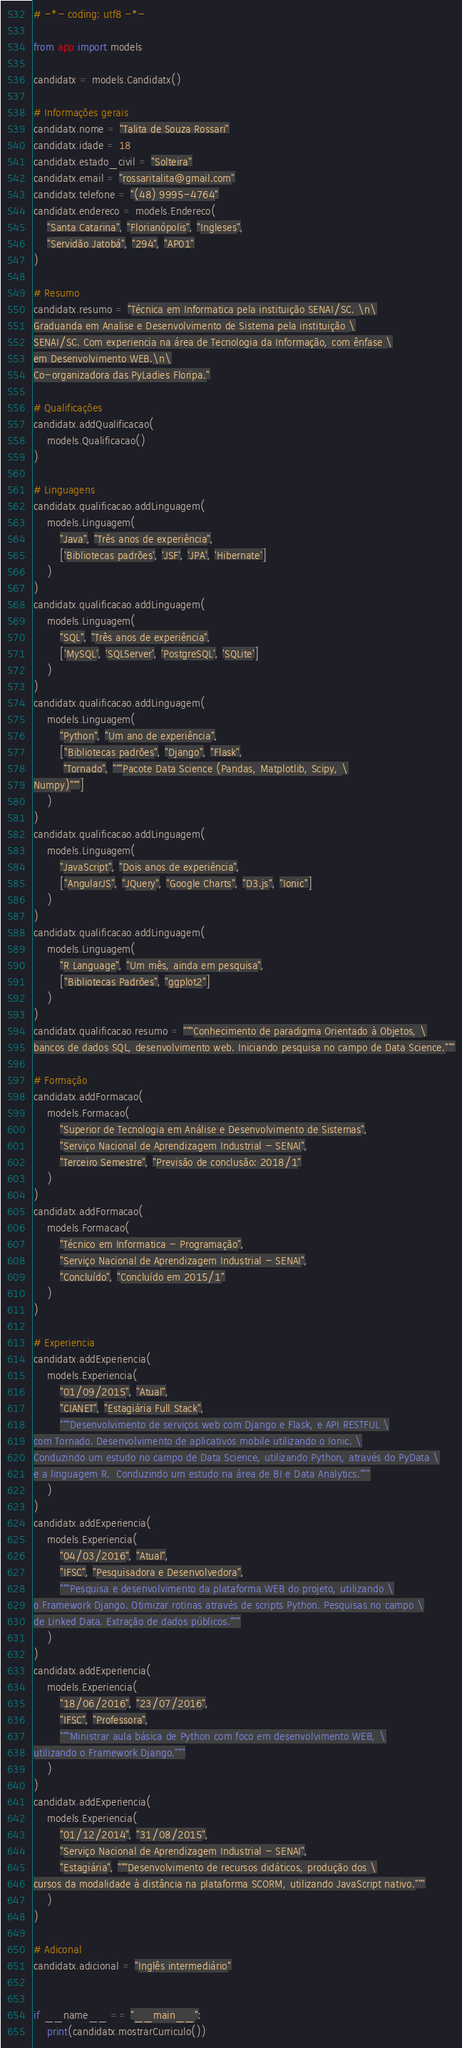Convert code to text. <code><loc_0><loc_0><loc_500><loc_500><_Python_># -*- coding: utf8 -*-

from app import models

candidatx = models.Candidatx()

# Informações gerais
candidatx.nome = "Talita de Souza Rossari"
candidatx.idade = 18
candidatx.estado_civil = "Solteira"
candidatx.email = "rossaritalita@gmail.com"
candidatx.telefone = "(48) 9995-4764"
candidatx.endereco = models.Endereco(
    "Santa Catarina", "Florianópolis", "Ingleses",
    "Servidão Jatobá", "294", "AP01"
)

# Resumo
candidatx.resumo = "Técnica em Informatica pela instituição SENAI/SC. \n\
Graduanda em Analise e Desenvolvimento de Sistema pela instituição \
SENAI/SC. Com experiencia na área de Tecnologia da Informação, com ênfase \
em Desenvolvimento WEB.\n\
Co-organizadora das PyLadies Floripa."

# Qualificações
candidatx.addQualificacao(
    models.Qualificacao()
)

# Linguagens
candidatx.qualificacao.addLinguagem(
    models.Linguagem(
        "Java", "Três anos de experiência",
        ['Bibliotecas padrões', 'JSF', 'JPA', 'Hibernate']
    )
)
candidatx.qualificacao.addLinguagem(
    models.Linguagem(
        "SQL", "Três anos de experiência",
        ['MySQL', 'SQLServer', 'PostgreSQL', 'SQLite']
    )
)
candidatx.qualificacao.addLinguagem(
    models.Linguagem(
        "Python", "Um ano de experiência",
        ["Bibliotecas padrões", "Django", "Flask",
         "Tornado", """Pacote Data Science (Pandas, Matplotlib, Scipy, \
Numpy)"""]
    )
)
candidatx.qualificacao.addLinguagem(
    models.Linguagem(
        "JavaScript", "Dois anos de experiência",
        ["AngularJS", "JQuery", "Google Charts", "D3.js", "Ionic"]
    )
)
candidatx.qualificacao.addLinguagem(
    models.Linguagem(
        "R Language", "Um mês, ainda em pesquisa",
        ["Bibliotecas Padrões", "ggplot2"]
    )
)
candidatx.qualificacao.resumo = """Conhecimento de paradigma Orientado à Objetos, \
bancos de dados SQL, desenvolvimento web. Iniciando pesquisa no campo de Data Science."""

# Formação
candidatx.addFormacao(
    models.Formacao(
        "Superior de Tecnologia em Análise e Desenvolvimento de Sistemas",
        "Serviço Nacional de Aprendizagem Industrial - SENAI",
        "Terceiro Semestre", "Previsão de conclusão: 2018/1"
    )
)
candidatx.addFormacao(
    models.Formacao(
        "Técnico em Informatica - Programação",
        "Serviço Nacional de Aprendizagem Industrial - SENAI",
        "Concluído", "Concluído em 2015/1"
    )
)

# Experiencia
candidatx.addExperiencia(
    models.Experiencia(
        "01/09/2015", "Atual",
        "CIANET", "Estagiária Full Stack",
        """Desenvolvimento de serviços web com Django e Flask, e API RESTFUL \
com Tornado. Desenvolvimento de aplicativos mobile utilizando o Ionic. \
Conduzindo um estudo no campo de Data Science, utilizando Python, através do PyData \
e a linguagem R.  Conduzindo um estudo na área de BI e Data Analytics."""
    )
)
candidatx.addExperiencia(
    models.Experiencia(
        "04/03/2016", "Atual",
        "IFSC", "Pesquisadora e Desenvolvedora",
        """Pesquisa e desenvolvimento da plataforma WEB do projeto, utilizando \
o Framework Django. Otimizar rotinas através de scripts Python. Pesquisas no campo \
de Linked Data. Extração de dados públicos."""
    )
)
candidatx.addExperiencia(
    models.Experiencia(
        "18/06/2016", "23/07/2016",
        "IFSC", "Professora",
        """Ministrar aula básica de Python com foco em desenvolvimento WEB, \
utilizando o Framework Django."""
    )
)
candidatx.addExperiencia(
    models.Experiencia(
        "01/12/2014", "31/08/2015",
        "Serviço Nacional de Aprendizagem Industrial - SENAI",
        "Estagiária", """Desenvolvimento de recursos didáticos, produção dos \
cursos da modalidade à distância na plataforma SCORM, utilizando JavaScript nativo."""
    )
)

# Adiconal
candidatx.adicional = "Inglês intermediário"


if __name__ == "__main__":
    print(candidatx.mostrarCurriculo())
</code> 